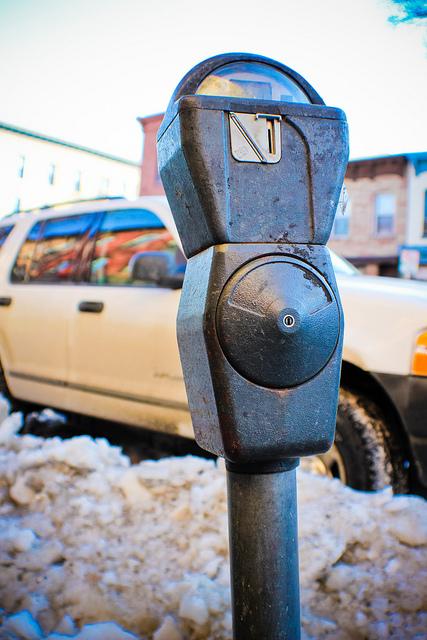How many meters are in the photo?
Give a very brief answer. 1. Has the time expired on the meter?
Answer briefly. No. Is it daytime?
Answer briefly. Yes. Is there time on the meter?
Concise answer only. No. What is next to the car?
Answer briefly. Meter. 